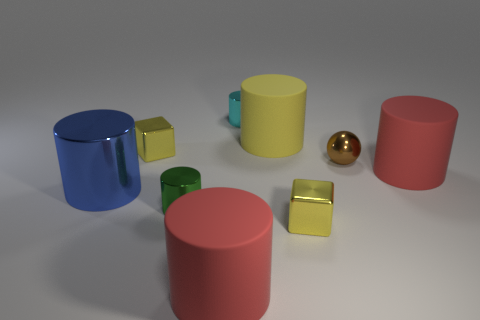There is a large rubber cylinder that is behind the brown metallic ball; is its color the same as the small ball?
Ensure brevity in your answer.  No. Does the shiny cylinder behind the brown sphere have the same size as the small green thing?
Ensure brevity in your answer.  Yes. Are there any rubber objects that have the same color as the tiny shiny sphere?
Offer a very short reply. No. There is a big red cylinder on the left side of the metal ball; is there a small yellow metal object on the left side of it?
Provide a succinct answer. Yes. Is there another tiny ball made of the same material as the ball?
Provide a short and direct response. No. The tiny yellow thing in front of the red object that is right of the brown sphere is made of what material?
Offer a terse response. Metal. What is the material of the small thing that is both in front of the blue cylinder and right of the yellow matte cylinder?
Give a very brief answer. Metal. Is the number of blue metal cylinders that are behind the cyan metal cylinder the same as the number of big brown metal blocks?
Offer a terse response. Yes. What number of yellow metal things are the same shape as the small cyan metal thing?
Give a very brief answer. 0. What size is the metallic cylinder that is behind the red object that is to the right of the large red rubber cylinder that is in front of the blue shiny cylinder?
Your answer should be compact. Small. 